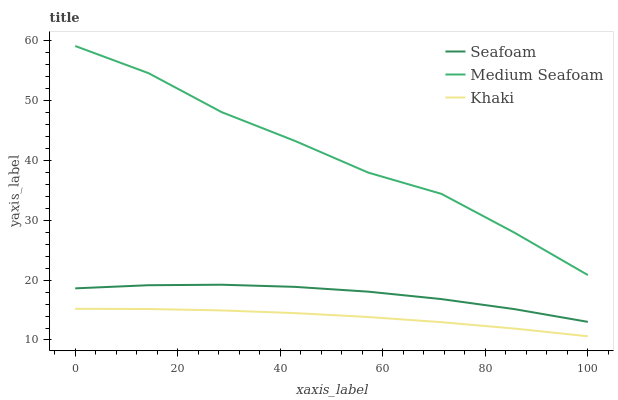Does Seafoam have the minimum area under the curve?
Answer yes or no. No. Does Seafoam have the maximum area under the curve?
Answer yes or no. No. Is Seafoam the smoothest?
Answer yes or no. No. Is Seafoam the roughest?
Answer yes or no. No. Does Seafoam have the lowest value?
Answer yes or no. No. Does Seafoam have the highest value?
Answer yes or no. No. Is Khaki less than Medium Seafoam?
Answer yes or no. Yes. Is Seafoam greater than Khaki?
Answer yes or no. Yes. Does Khaki intersect Medium Seafoam?
Answer yes or no. No. 